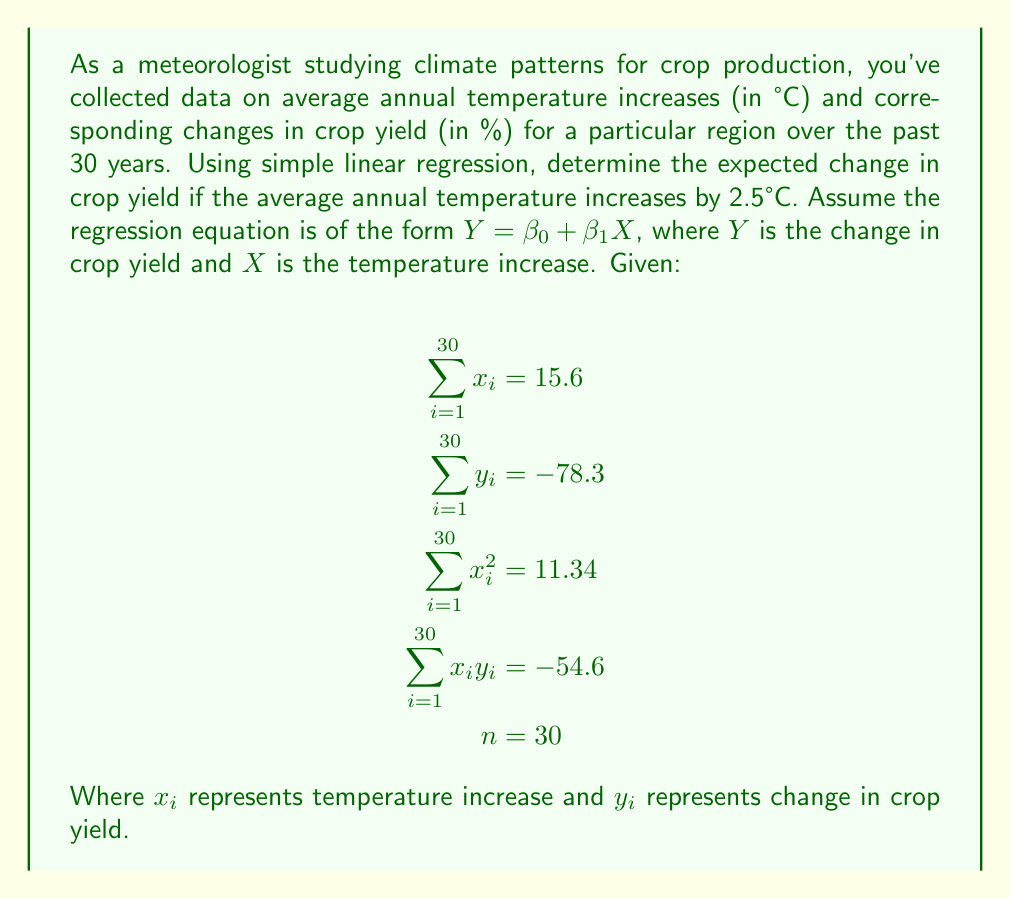Can you answer this question? To solve this problem, we need to follow these steps:

1. Calculate the slope ($\beta_1$) and y-intercept ($\beta_0$) of the regression line.
2. Form the regression equation.
3. Use the equation to predict the change in crop yield for a 2.5°C temperature increase.

Step 1: Calculate $\beta_1$ and $\beta_0$

The formula for the slope $\beta_1$ is:

$$\beta_1 = \frac{n\sum x_iy_i - \sum x_i \sum y_i}{n\sum x_i^2 - (\sum x_i)^2}$$

Substituting the given values:

$$\beta_1 = \frac{30(-54.6) - (15.6)(-78.3)}{30(11.34) - (15.6)^2}$$
$$= \frac{-1638 + 1221.48}{340.2 - 243.36}$$
$$= \frac{-416.52}{96.84} = -4.30$$

Now, we can calculate the y-intercept $\beta_0$ using the formula:

$$\beta_0 = \frac{\sum y_i - \beta_1 \sum x_i}{n}$$

Substituting the values:

$$\beta_0 = \frac{-78.3 - (-4.30)(15.6)}{30}$$
$$= \frac{-78.3 + 67.08}{30} = -0.37$$

Step 2: Form the regression equation

The regression equation is:

$$Y = -0.37 - 4.30X$$

Step 3: Predict the change in crop yield for a 2.5°C temperature increase

Substitute $X = 2.5$ into the equation:

$$Y = -0.37 - 4.30(2.5) = -0.37 - 10.75 = -11.12$$

Therefore, the expected change in crop yield for a 2.5°C temperature increase is -11.12%.
Answer: The expected change in crop yield for a 2.5°C temperature increase is -11.12%. 